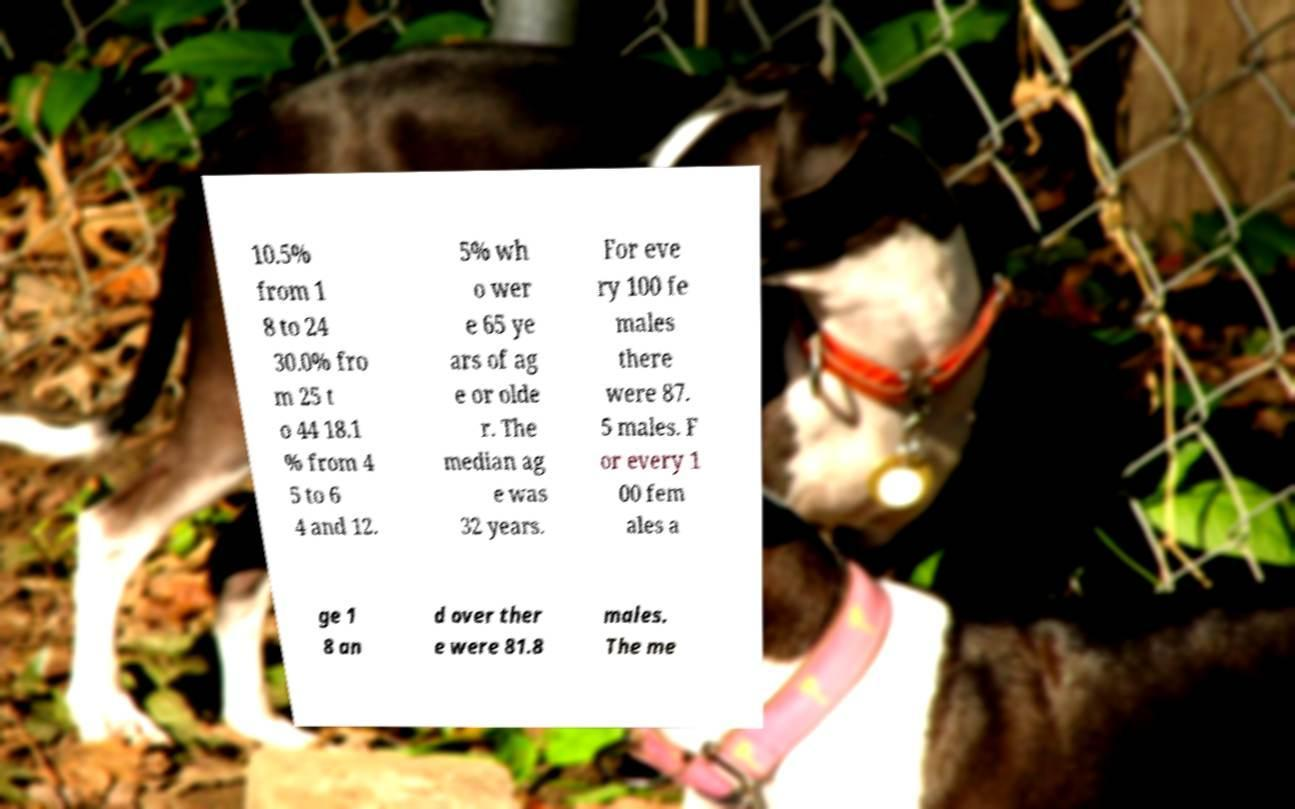What messages or text are displayed in this image? I need them in a readable, typed format. 10.5% from 1 8 to 24 30.0% fro m 25 t o 44 18.1 % from 4 5 to 6 4 and 12. 5% wh o wer e 65 ye ars of ag e or olde r. The median ag e was 32 years. For eve ry 100 fe males there were 87. 5 males. F or every 1 00 fem ales a ge 1 8 an d over ther e were 81.8 males. The me 